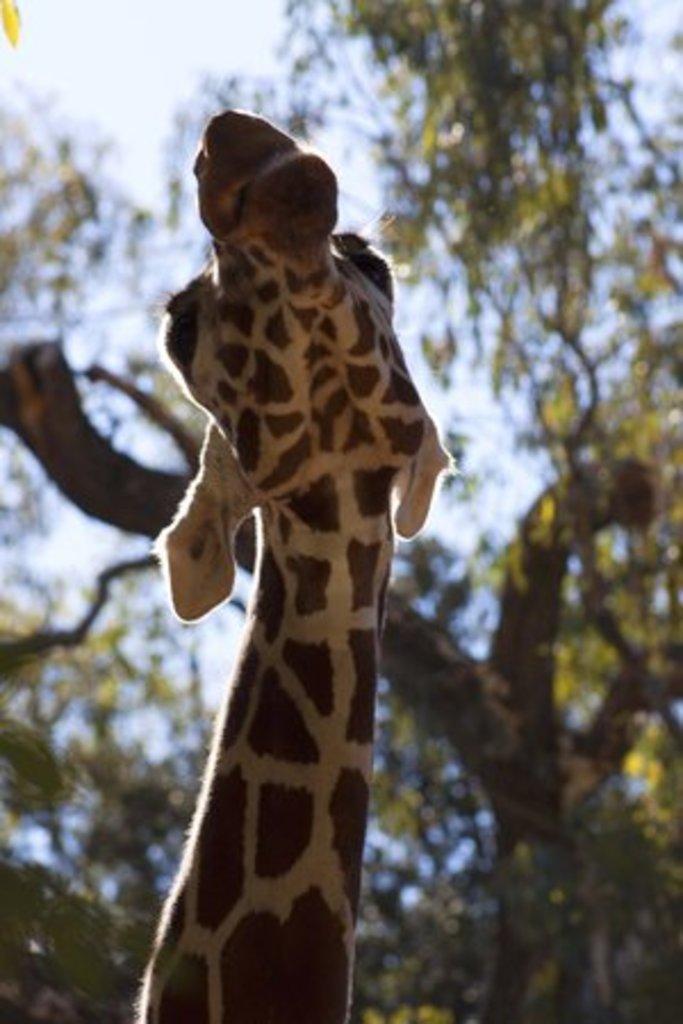How would you summarize this image in a sentence or two? In this picture there is a giraffe in the foreground. At the back there are trees. At the top there is sky. 